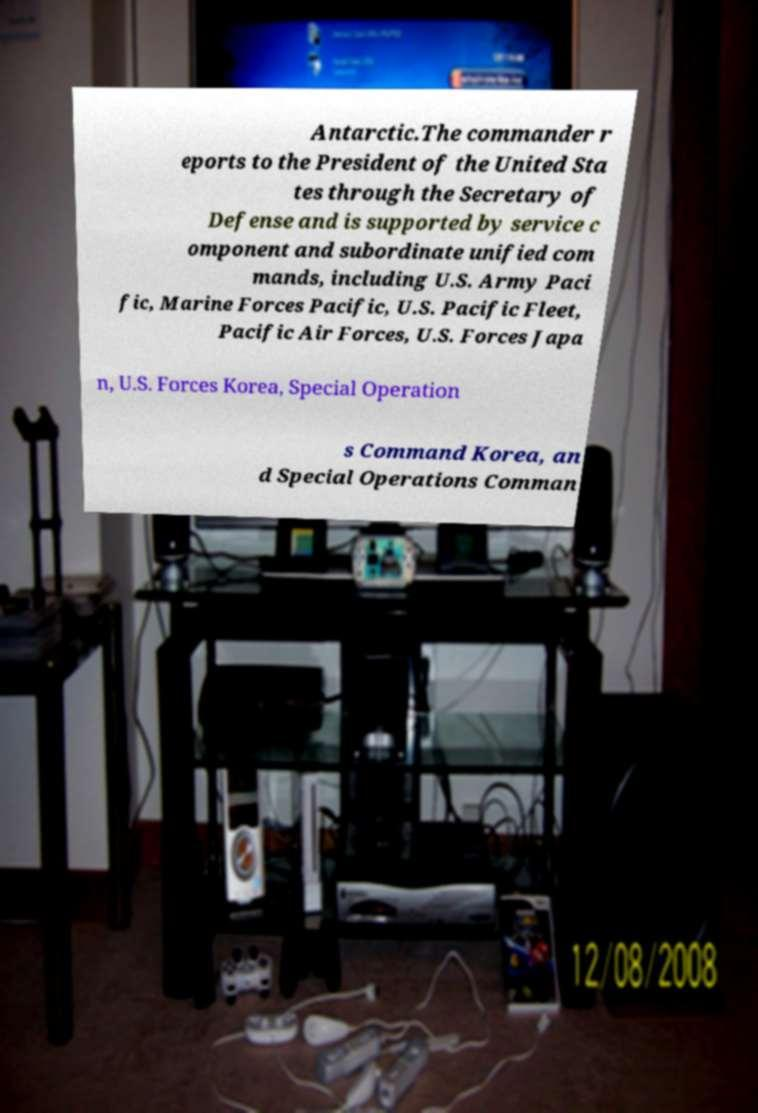Could you extract and type out the text from this image? Antarctic.The commander r eports to the President of the United Sta tes through the Secretary of Defense and is supported by service c omponent and subordinate unified com mands, including U.S. Army Paci fic, Marine Forces Pacific, U.S. Pacific Fleet, Pacific Air Forces, U.S. Forces Japa n, U.S. Forces Korea, Special Operation s Command Korea, an d Special Operations Comman 